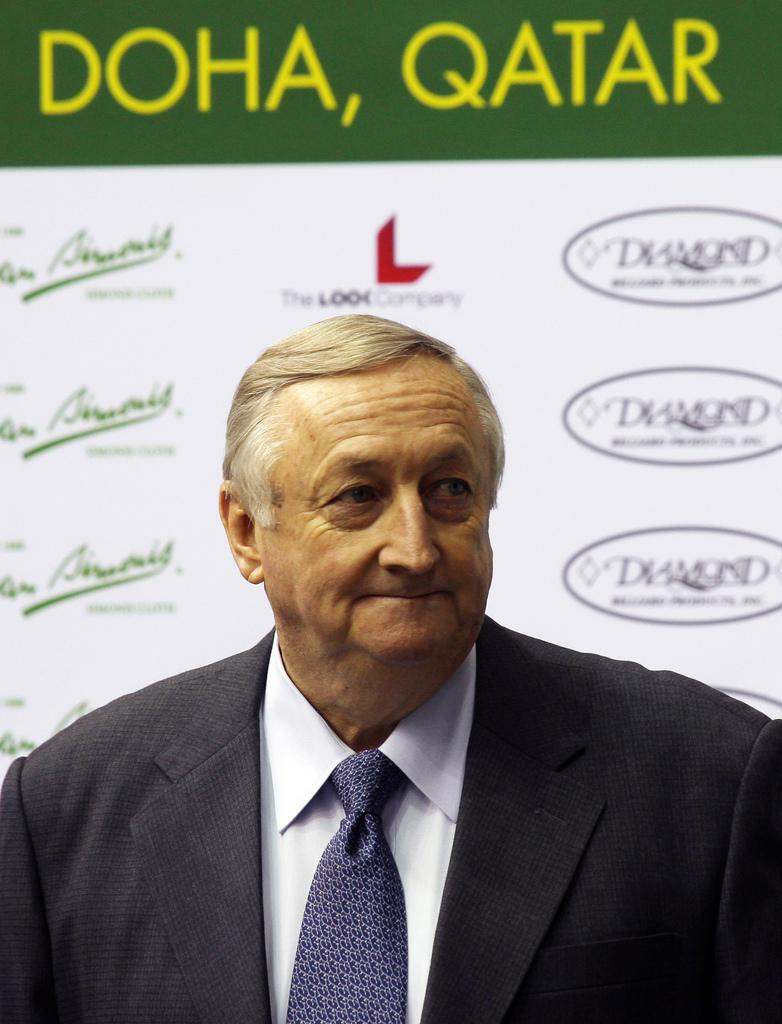Who is the main subject in the picture? There is an old man in the picture. What is the old man wearing? The old man is wearing a black coat. In which direction is the old man looking? The old man is looking to the right side. What can be seen in the background of the picture? There is a white and green color banner in the background. What is written on the banner? The banner has "Doha Qatar" written on it. Does the old man have a son standing next to him in the picture? There is no mention of a son in the provided facts, so we cannot determine if the old man has a son standing next to him in the picture. What type of frame is the picture displayed in? The provided facts do not mention a frame, so we cannot determine the type of frame the picture is displayed in. 